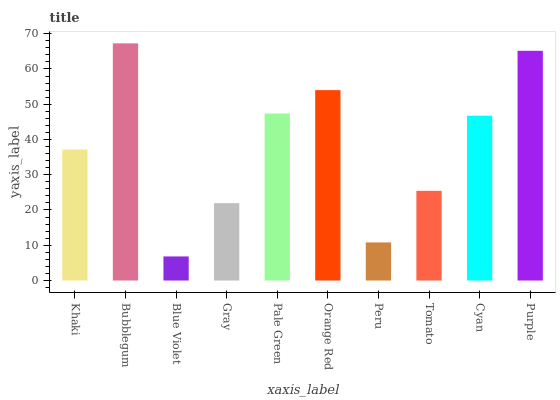Is Blue Violet the minimum?
Answer yes or no. Yes. Is Bubblegum the maximum?
Answer yes or no. Yes. Is Bubblegum the minimum?
Answer yes or no. No. Is Blue Violet the maximum?
Answer yes or no. No. Is Bubblegum greater than Blue Violet?
Answer yes or no. Yes. Is Blue Violet less than Bubblegum?
Answer yes or no. Yes. Is Blue Violet greater than Bubblegum?
Answer yes or no. No. Is Bubblegum less than Blue Violet?
Answer yes or no. No. Is Cyan the high median?
Answer yes or no. Yes. Is Khaki the low median?
Answer yes or no. Yes. Is Bubblegum the high median?
Answer yes or no. No. Is Cyan the low median?
Answer yes or no. No. 